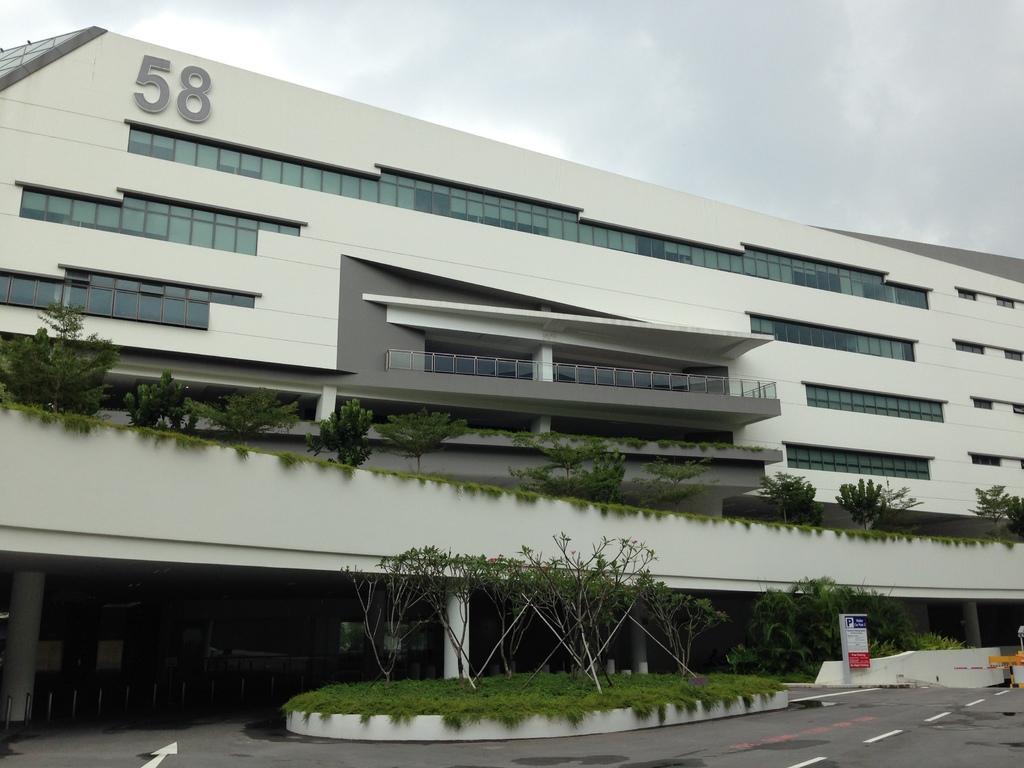Could you give a brief overview of what you see in this image? In the foreground of the image we can see road, grass and plants. In the middle of the image we can see a building and on it a number is written. On the top of the image we can see the sky. 